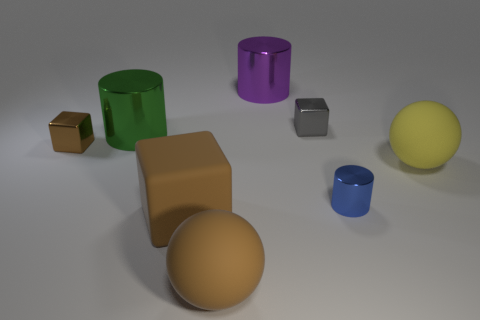Subtract all metallic cubes. How many cubes are left? 1 Subtract all gray blocks. How many blocks are left? 2 Subtract all cylinders. How many objects are left? 5 Subtract 1 cylinders. How many cylinders are left? 2 Add 1 gray shiny cylinders. How many objects exist? 9 Subtract all cyan cylinders. How many brown blocks are left? 2 Subtract 0 yellow cubes. How many objects are left? 8 Subtract all brown spheres. Subtract all brown blocks. How many spheres are left? 1 Subtract all big objects. Subtract all tiny blue rubber objects. How many objects are left? 3 Add 4 small metallic blocks. How many small metallic blocks are left? 6 